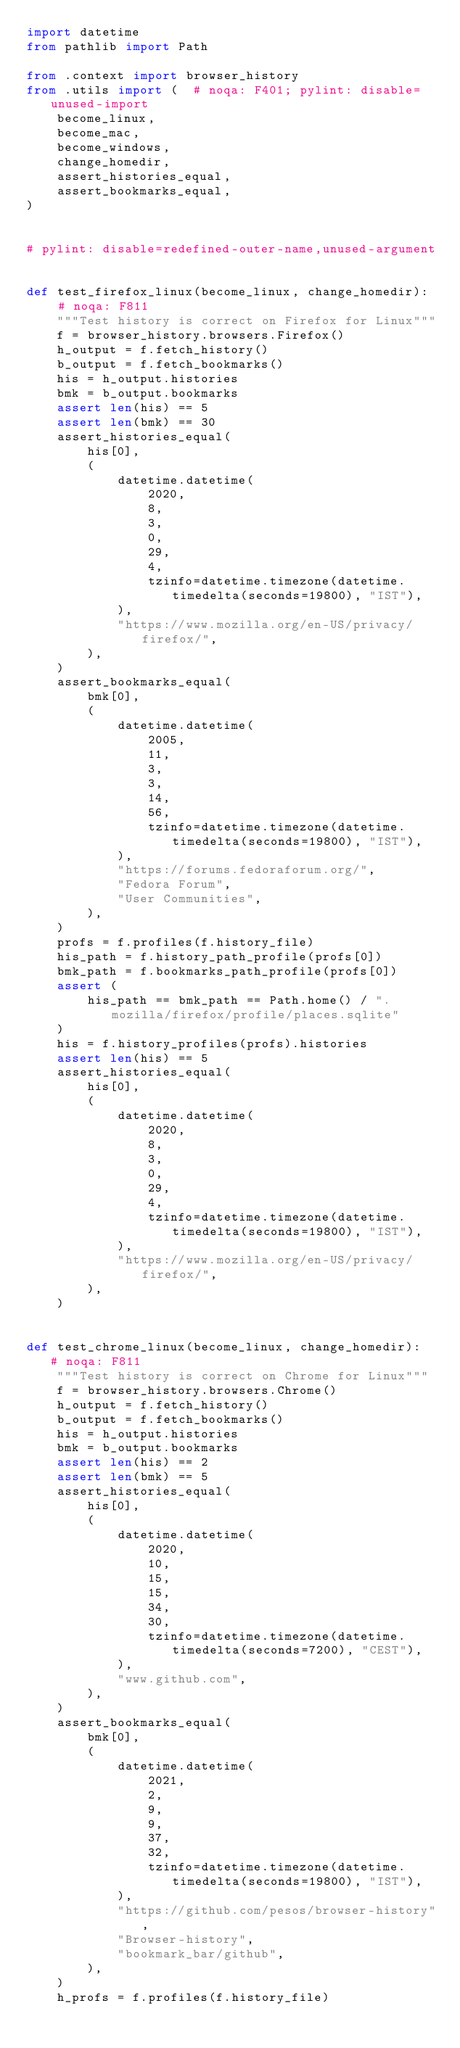<code> <loc_0><loc_0><loc_500><loc_500><_Python_>import datetime
from pathlib import Path

from .context import browser_history
from .utils import (  # noqa: F401; pylint: disable=unused-import
    become_linux,
    become_mac,
    become_windows,
    change_homedir,
    assert_histories_equal,
    assert_bookmarks_equal,
)


# pylint: disable=redefined-outer-name,unused-argument


def test_firefox_linux(become_linux, change_homedir):  # noqa: F811
    """Test history is correct on Firefox for Linux"""
    f = browser_history.browsers.Firefox()
    h_output = f.fetch_history()
    b_output = f.fetch_bookmarks()
    his = h_output.histories
    bmk = b_output.bookmarks
    assert len(his) == 5
    assert len(bmk) == 30
    assert_histories_equal(
        his[0],
        (
            datetime.datetime(
                2020,
                8,
                3,
                0,
                29,
                4,
                tzinfo=datetime.timezone(datetime.timedelta(seconds=19800), "IST"),
            ),
            "https://www.mozilla.org/en-US/privacy/firefox/",
        ),
    )
    assert_bookmarks_equal(
        bmk[0],
        (
            datetime.datetime(
                2005,
                11,
                3,
                3,
                14,
                56,
                tzinfo=datetime.timezone(datetime.timedelta(seconds=19800), "IST"),
            ),
            "https://forums.fedoraforum.org/",
            "Fedora Forum",
            "User Communities",
        ),
    )
    profs = f.profiles(f.history_file)
    his_path = f.history_path_profile(profs[0])
    bmk_path = f.bookmarks_path_profile(profs[0])
    assert (
        his_path == bmk_path == Path.home() / ".mozilla/firefox/profile/places.sqlite"
    )
    his = f.history_profiles(profs).histories
    assert len(his) == 5
    assert_histories_equal(
        his[0],
        (
            datetime.datetime(
                2020,
                8,
                3,
                0,
                29,
                4,
                tzinfo=datetime.timezone(datetime.timedelta(seconds=19800), "IST"),
            ),
            "https://www.mozilla.org/en-US/privacy/firefox/",
        ),
    )


def test_chrome_linux(become_linux, change_homedir):  # noqa: F811
    """Test history is correct on Chrome for Linux"""
    f = browser_history.browsers.Chrome()
    h_output = f.fetch_history()
    b_output = f.fetch_bookmarks()
    his = h_output.histories
    bmk = b_output.bookmarks
    assert len(his) == 2
    assert len(bmk) == 5
    assert_histories_equal(
        his[0],
        (
            datetime.datetime(
                2020,
                10,
                15,
                15,
                34,
                30,
                tzinfo=datetime.timezone(datetime.timedelta(seconds=7200), "CEST"),
            ),
            "www.github.com",
        ),
    )
    assert_bookmarks_equal(
        bmk[0],
        (
            datetime.datetime(
                2021,
                2,
                9,
                9,
                37,
                32,
                tzinfo=datetime.timezone(datetime.timedelta(seconds=19800), "IST"),
            ),
            "https://github.com/pesos/browser-history",
            "Browser-history",
            "bookmark_bar/github",
        ),
    )
    h_profs = f.profiles(f.history_file)</code> 